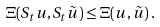<formula> <loc_0><loc_0><loc_500><loc_500>\Xi ( S _ { t } u , S _ { t } \tilde { u } ) \leq \Xi ( u , \tilde { u } ) \, .</formula> 